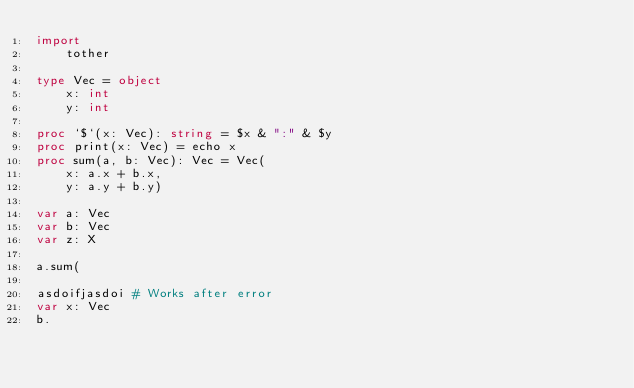<code> <loc_0><loc_0><loc_500><loc_500><_Nim_>import
    tother

type Vec = object
    x: int
    y: int

proc `$`(x: Vec): string = $x & ":" & $y
proc print(x: Vec) = echo x
proc sum(a, b: Vec): Vec = Vec(
    x: a.x + b.x,
    y: a.y + b.y)

var a: Vec
var b: Vec
var z: X

a.sum(

asdoifjasdoi # Works after error
var x: Vec
b.
</code> 